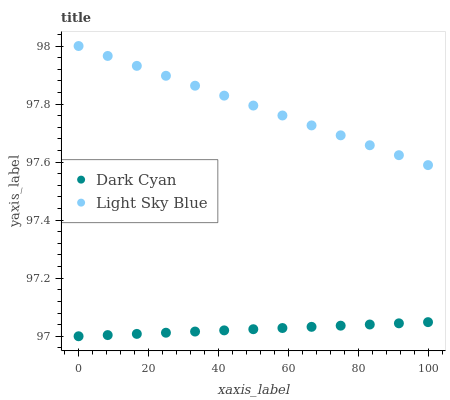Does Dark Cyan have the minimum area under the curve?
Answer yes or no. Yes. Does Light Sky Blue have the maximum area under the curve?
Answer yes or no. Yes. Does Light Sky Blue have the minimum area under the curve?
Answer yes or no. No. Is Dark Cyan the smoothest?
Answer yes or no. Yes. Is Light Sky Blue the roughest?
Answer yes or no. Yes. Is Light Sky Blue the smoothest?
Answer yes or no. No. Does Dark Cyan have the lowest value?
Answer yes or no. Yes. Does Light Sky Blue have the lowest value?
Answer yes or no. No. Does Light Sky Blue have the highest value?
Answer yes or no. Yes. Is Dark Cyan less than Light Sky Blue?
Answer yes or no. Yes. Is Light Sky Blue greater than Dark Cyan?
Answer yes or no. Yes. Does Dark Cyan intersect Light Sky Blue?
Answer yes or no. No. 